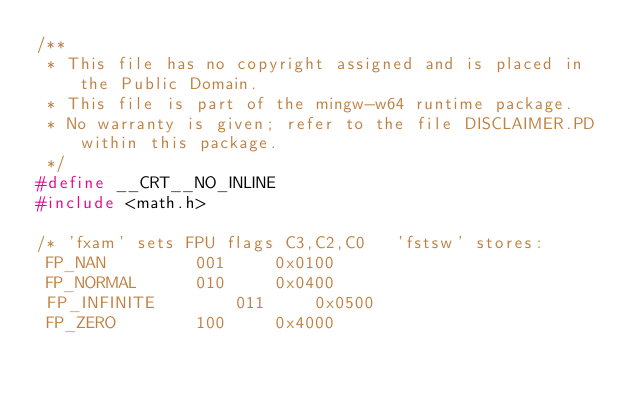<code> <loc_0><loc_0><loc_500><loc_500><_C_>/**
 * This file has no copyright assigned and is placed in the Public Domain.
 * This file is part of the mingw-w64 runtime package.
 * No warranty is given; refer to the file DISCLAIMER.PD within this package.
 */
#define __CRT__NO_INLINE
#include <math.h>

/* 'fxam' sets FPU flags C3,C2,C0   'fstsw' stores: 
 FP_NAN			001		0x0100
 FP_NORMAL		010		0x0400
 FP_INFINITE		011		0x0500
 FP_ZERO		100		0x4000</code> 